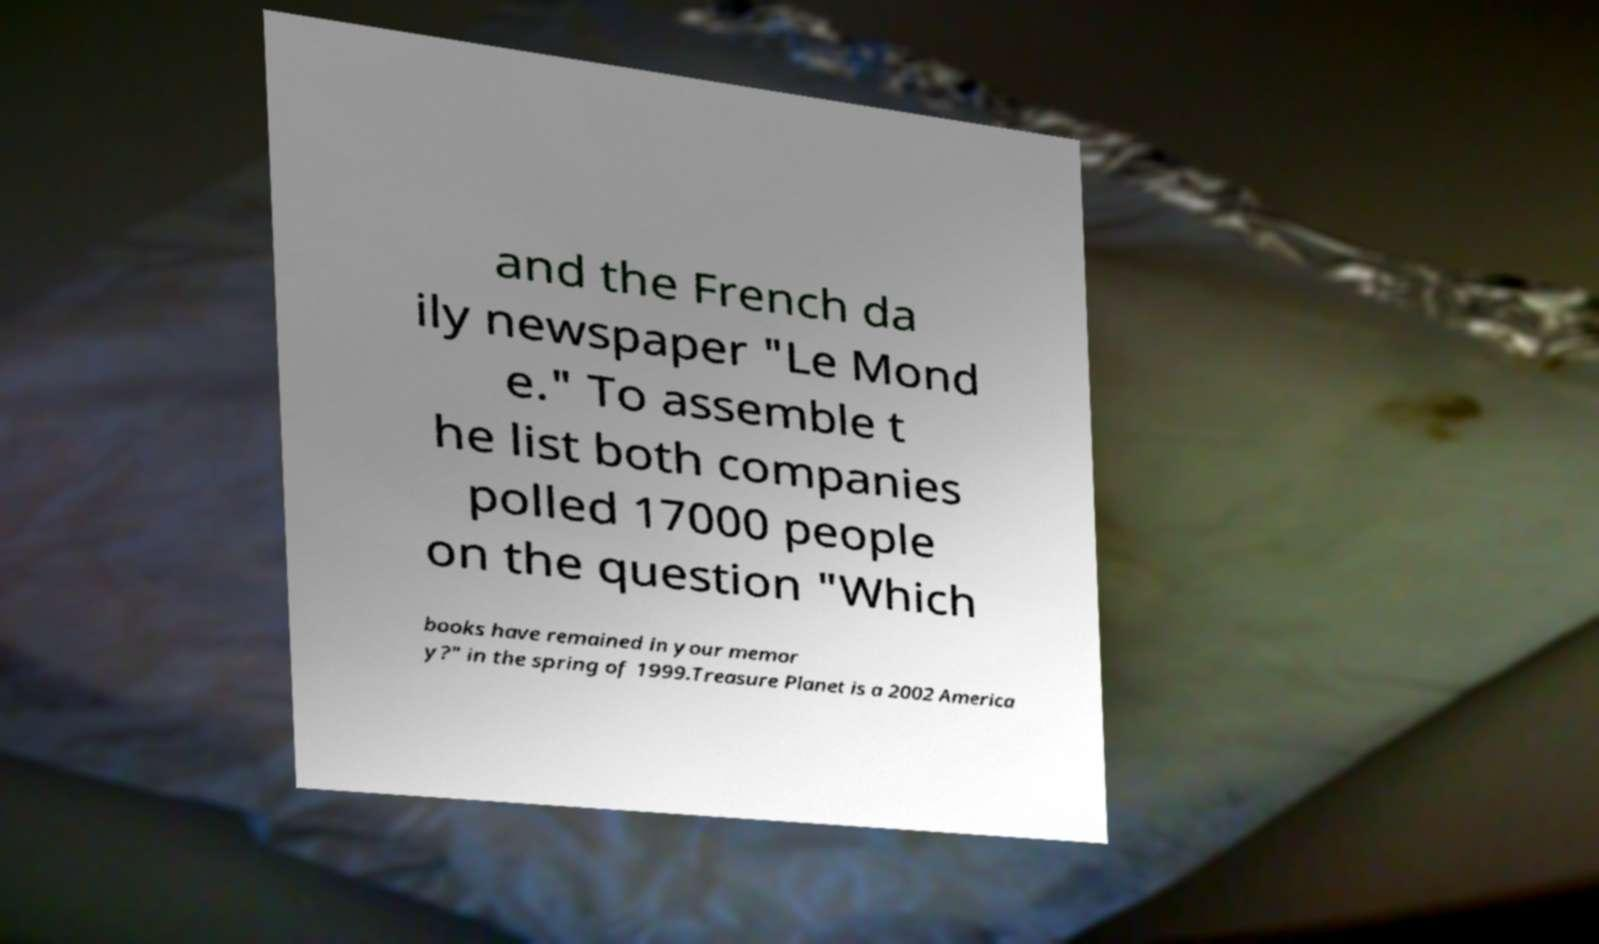Could you extract and type out the text from this image? and the French da ily newspaper "Le Mond e." To assemble t he list both companies polled 17000 people on the question "Which books have remained in your memor y?" in the spring of 1999.Treasure Planet is a 2002 America 